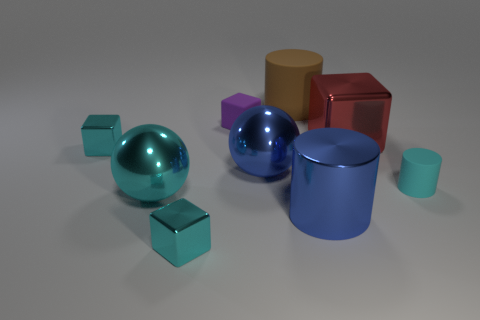Are there any brown matte cylinders of the same size as the cyan metal ball?
Offer a terse response. Yes. What is the color of the other tiny rubber object that is the same shape as the brown thing?
Offer a very short reply. Cyan. Is there a blue metallic cylinder to the left of the tiny cyan metallic cube that is behind the small cylinder?
Your answer should be very brief. No. There is a big thing behind the purple cube; is its shape the same as the tiny purple thing?
Give a very brief answer. No. There is a cyan matte object; what shape is it?
Offer a very short reply. Cylinder. What number of blue things have the same material as the big block?
Offer a very short reply. 2. There is a tiny matte cylinder; is its color the same as the tiny metallic thing in front of the blue metal cylinder?
Provide a short and direct response. Yes. How many cyan objects are there?
Provide a short and direct response. 4. Is there a object that has the same color as the big shiny cylinder?
Keep it short and to the point. Yes. The small object that is behind the large object to the right of the blue metal thing that is right of the large brown object is what color?
Your answer should be compact. Purple. 